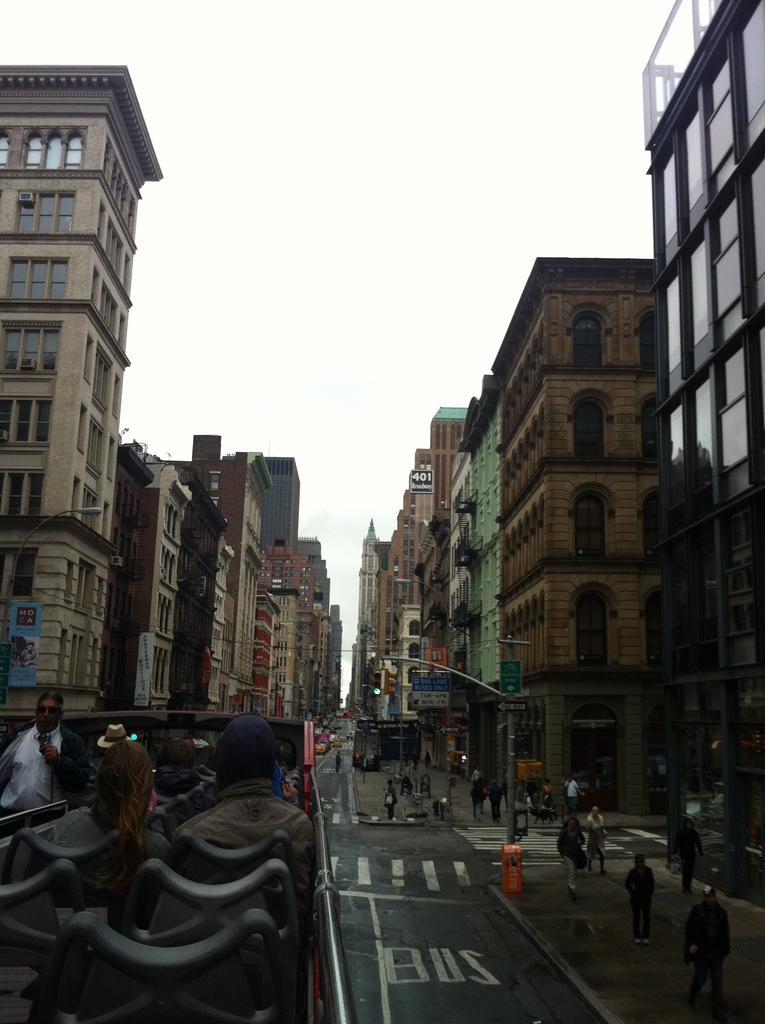How would you summarize this image in a sentence or two? In the picture we can see many buildings with windows and between the buildings we can see a road with zebra lines and a path with some people are walking and we can see a pole with light and on the road we can see a bus on it we can see some people are sitting on the seats and in the background we can see the sky. 